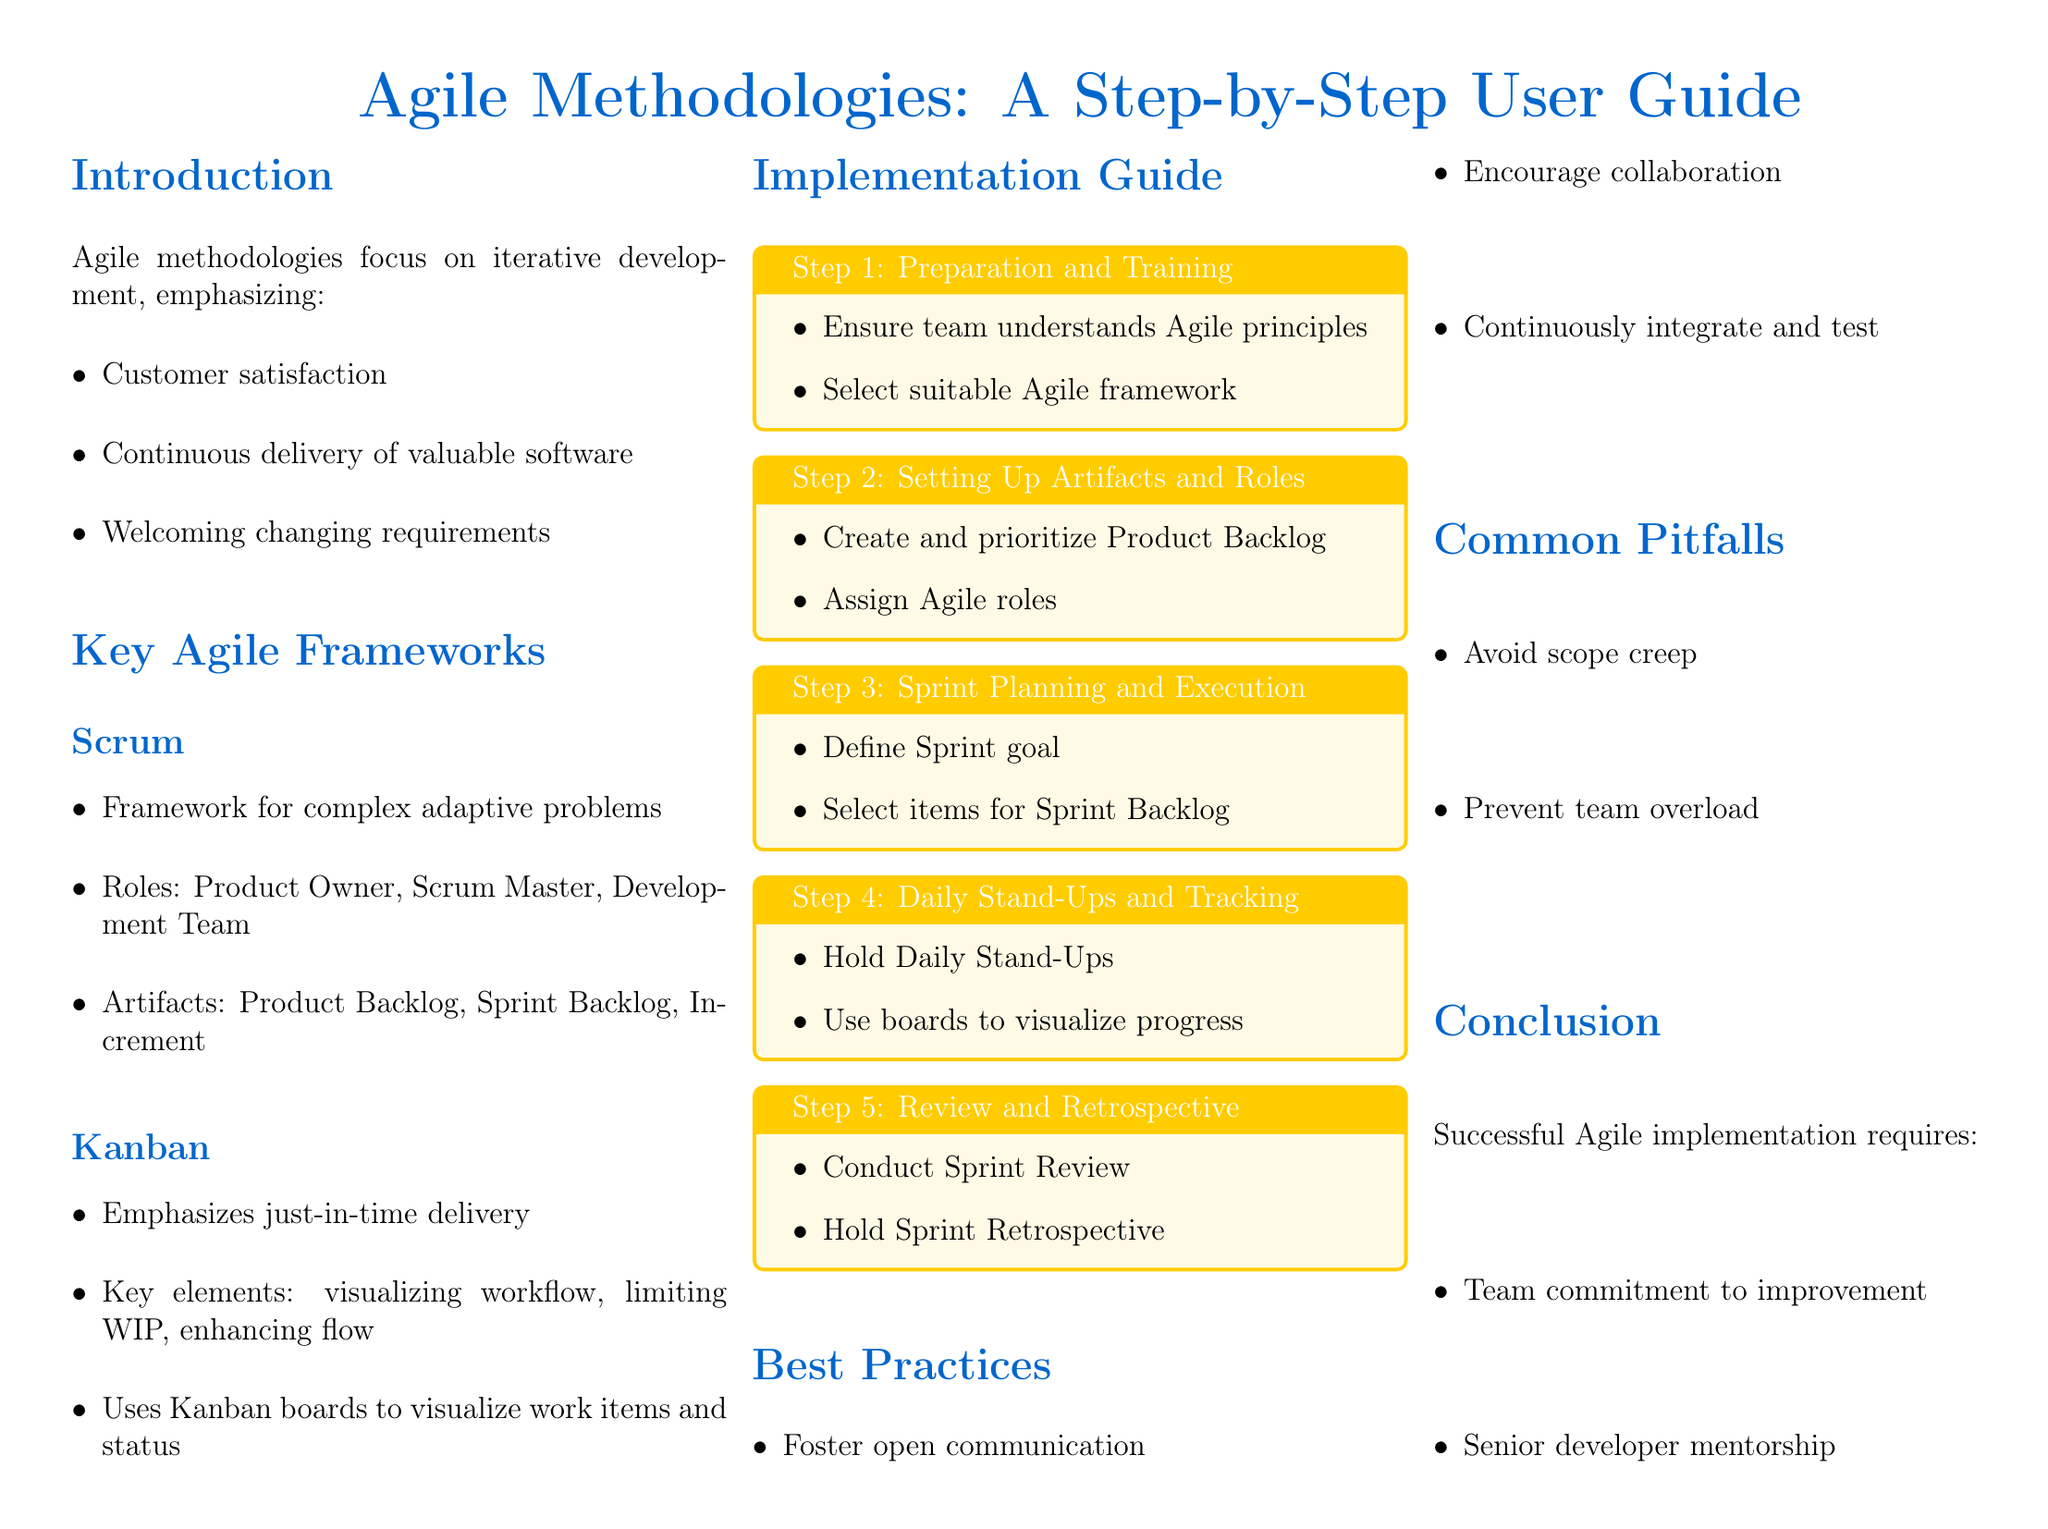what is the main focus of Agile methodologies? Agile methodologies focus on iterative development, emphasizing customer satisfaction, continuous delivery of valuable software, and welcoming changing requirements.
Answer: iterative development name the three roles in Scrum The roles in Scrum are the Product Owner, Scrum Master, and Development Team.
Answer: Product Owner, Scrum Master, Development Team what are the key elements of Kanban? The key elements of Kanban include visualizing workflow, limiting WIP, and enhancing flow.
Answer: visualizing workflow, limiting WIP, enhancing flow what is the first step in the implementation guide? The first step in the implementation guide is Preparation and Training.
Answer: Preparation and Training how many steps are listed in the implementation guide? The document lists five steps in the implementation guide.
Answer: five what is one best practice mentioned in the document? One best practice mentioned in the document is to foster open communication.
Answer: foster open communication what is a common pitfall in Agile projects? A common pitfall in Agile projects is scope creep.
Answer: scope creep what is the senior developer's responsibility? The senior developer's responsibility includes monitoring the student's progress closely.
Answer: monitoring student's progress closely 